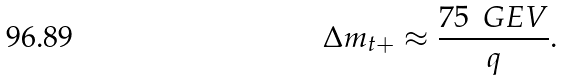Convert formula to latex. <formula><loc_0><loc_0><loc_500><loc_500>\Delta m _ { t + } \approx \frac { 7 5 \, \ G E V } { q } .</formula> 